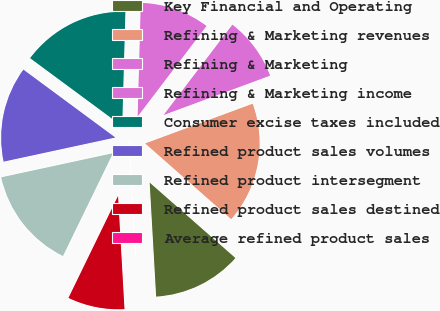Convert chart to OTSL. <chart><loc_0><loc_0><loc_500><loc_500><pie_chart><fcel>Key Financial and Operating<fcel>Refining & Marketing revenues<fcel>Refining & Marketing<fcel>Refining & Marketing income<fcel>Consumer excise taxes included<fcel>Refined product sales volumes<fcel>Refined product intersegment<fcel>Refined product sales destined<fcel>Average refined product sales<nl><fcel>12.61%<fcel>17.12%<fcel>9.01%<fcel>9.91%<fcel>15.32%<fcel>13.51%<fcel>14.41%<fcel>8.11%<fcel>0.0%<nl></chart> 